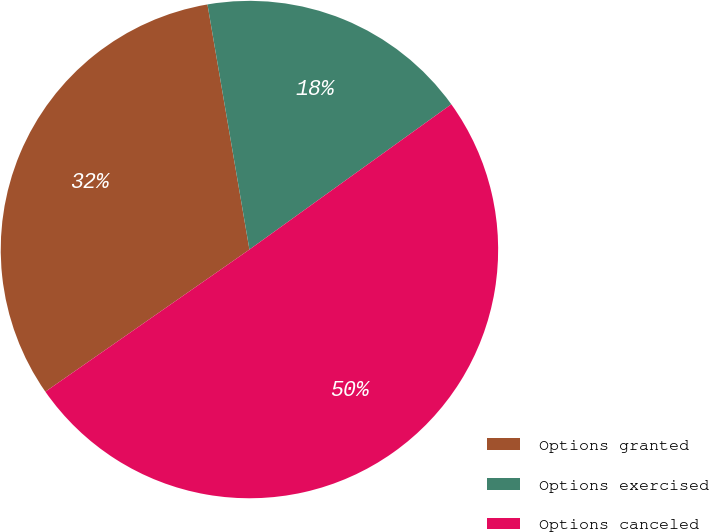Convert chart. <chart><loc_0><loc_0><loc_500><loc_500><pie_chart><fcel>Options granted<fcel>Options exercised<fcel>Options canceled<nl><fcel>31.98%<fcel>17.77%<fcel>50.24%<nl></chart> 